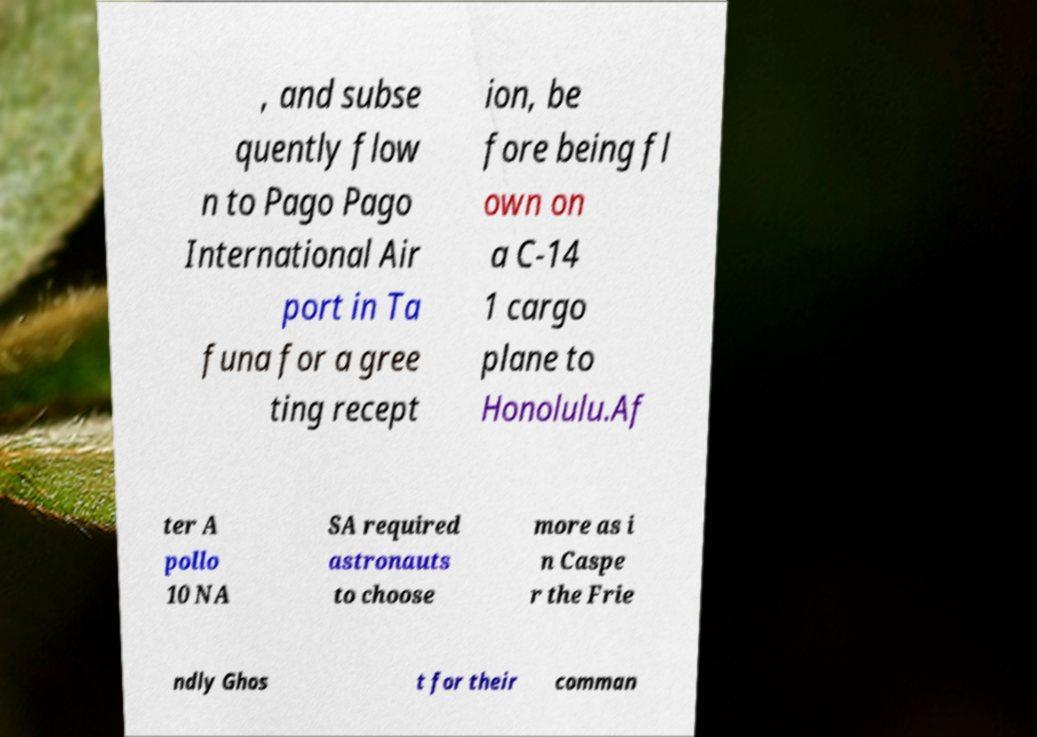There's text embedded in this image that I need extracted. Can you transcribe it verbatim? , and subse quently flow n to Pago Pago International Air port in Ta funa for a gree ting recept ion, be fore being fl own on a C-14 1 cargo plane to Honolulu.Af ter A pollo 10 NA SA required astronauts to choose more as i n Caspe r the Frie ndly Ghos t for their comman 